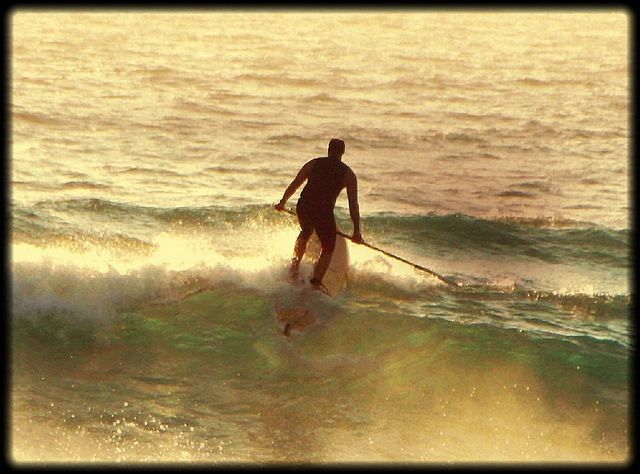Describe the objects in this image and their specific colors. I can see people in black, maroon, khaki, and brown tones and surfboard in black, maroon, brown, and gray tones in this image. 